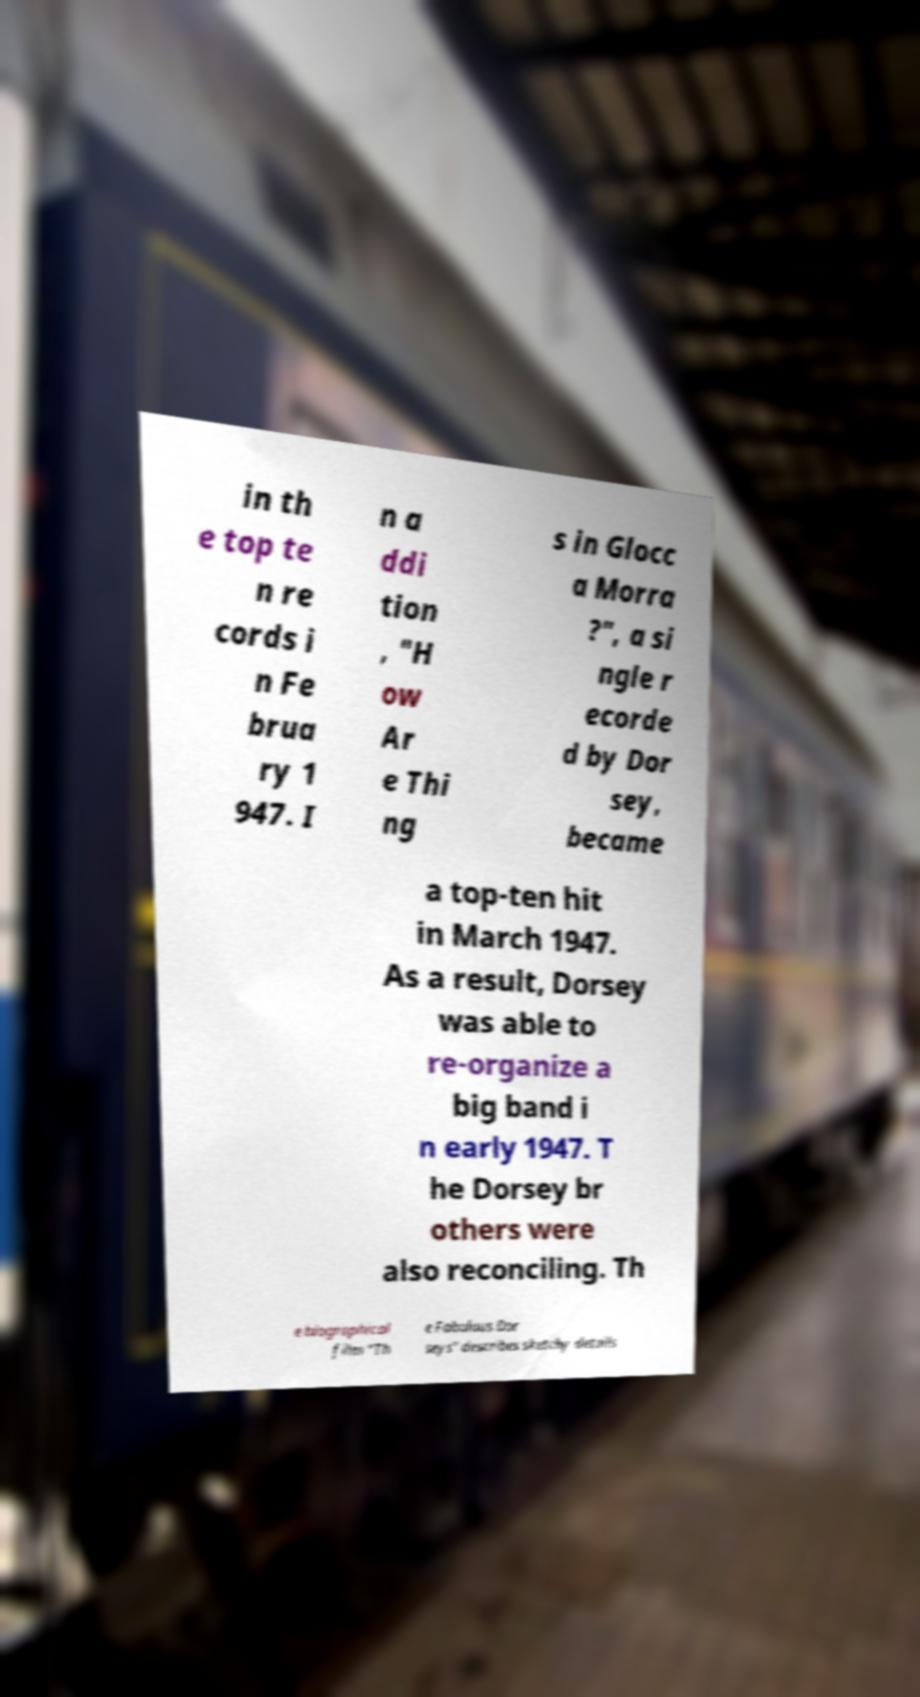Could you extract and type out the text from this image? in th e top te n re cords i n Fe brua ry 1 947. I n a ddi tion , "H ow Ar e Thi ng s in Glocc a Morra ?", a si ngle r ecorde d by Dor sey, became a top-ten hit in March 1947. As a result, Dorsey was able to re-organize a big band i n early 1947. T he Dorsey br others were also reconciling. Th e biographical film "Th e Fabulous Dor seys" describes sketchy details 